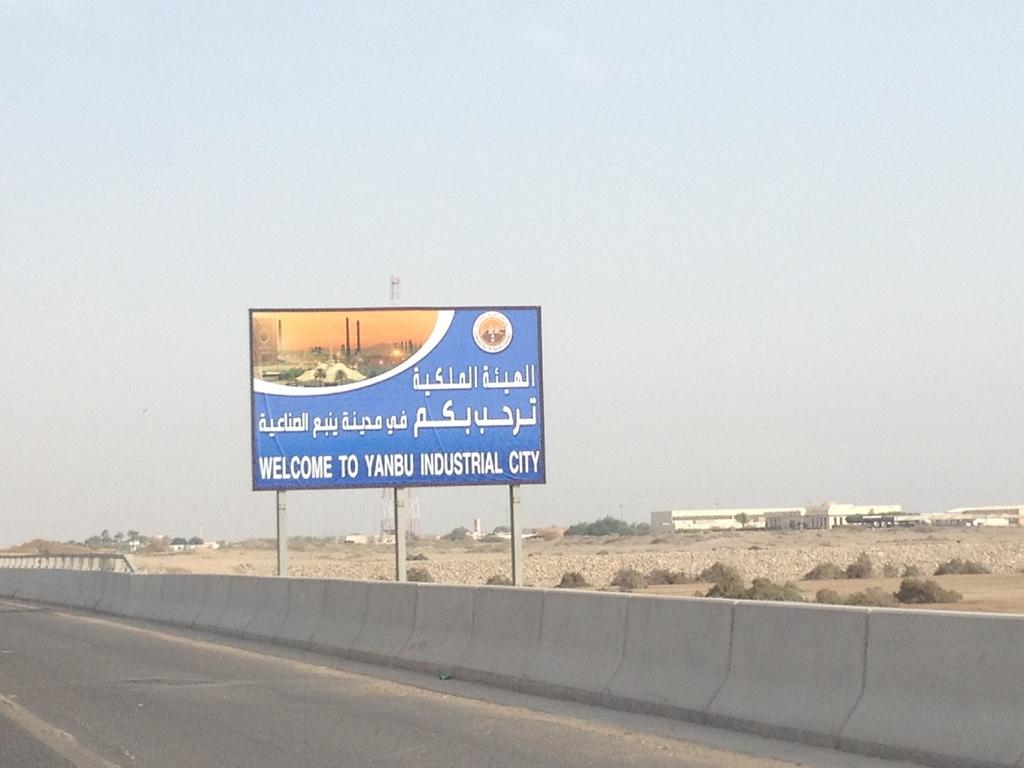<image>
Write a terse but informative summary of the picture. The road sign supplies the English translation of Welcome to Yanbu Industrial City. 